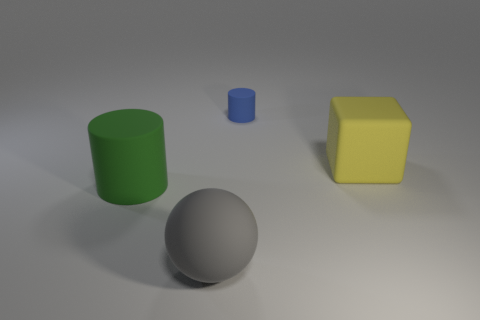Add 2 big green cylinders. How many objects exist? 6 Subtract all green cylinders. How many cylinders are left? 1 Add 4 big brown matte things. How many big brown matte things exist? 4 Subtract 0 purple spheres. How many objects are left? 4 Subtract all blocks. How many objects are left? 3 Subtract all red cubes. Subtract all gray cylinders. How many cubes are left? 1 Subtract all big green metallic cubes. Subtract all blue matte things. How many objects are left? 3 Add 2 matte objects. How many matte objects are left? 6 